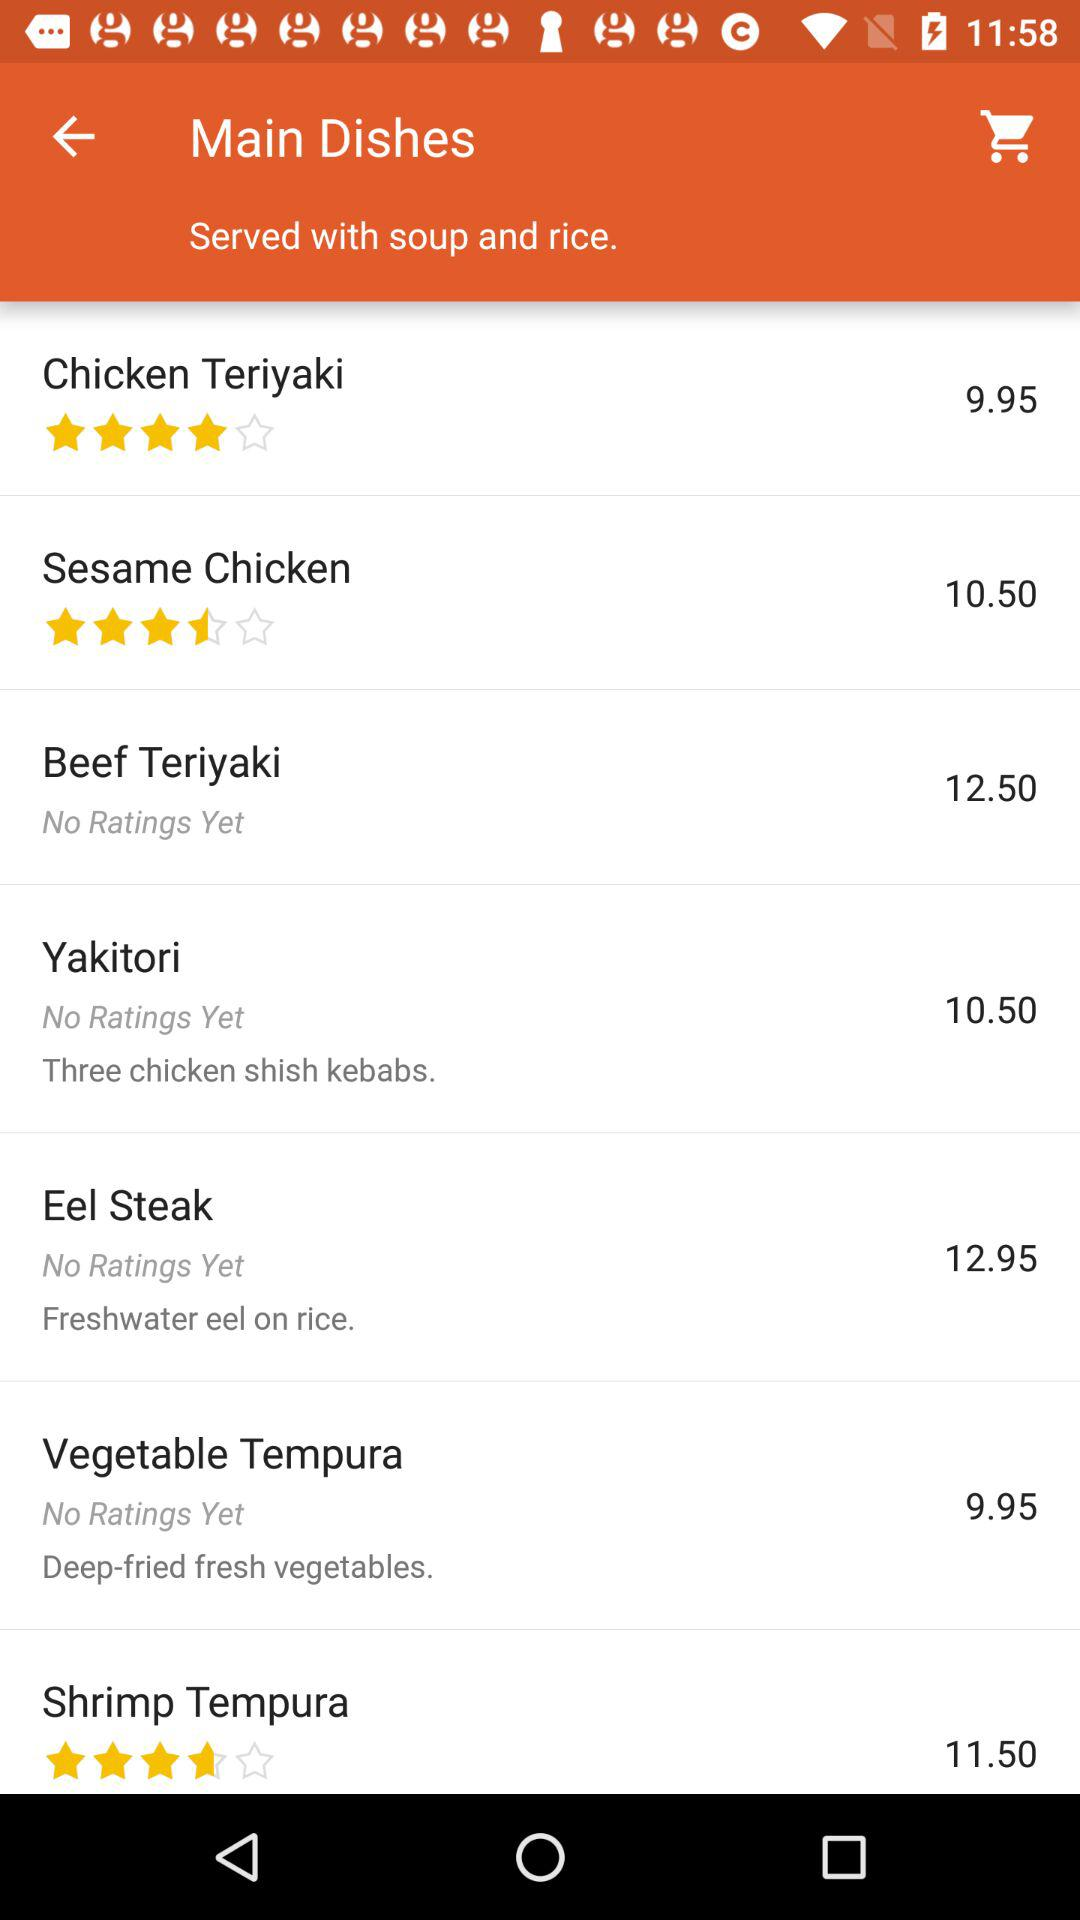What are the main dishes available? The available main dishes are: "Chicken Teriyaki", "Sesame Chicken", "Beef Teriyaki", "Yakitori", "Eel Steak", "Vegetable Tempura", and "Shrimp Tempura". 